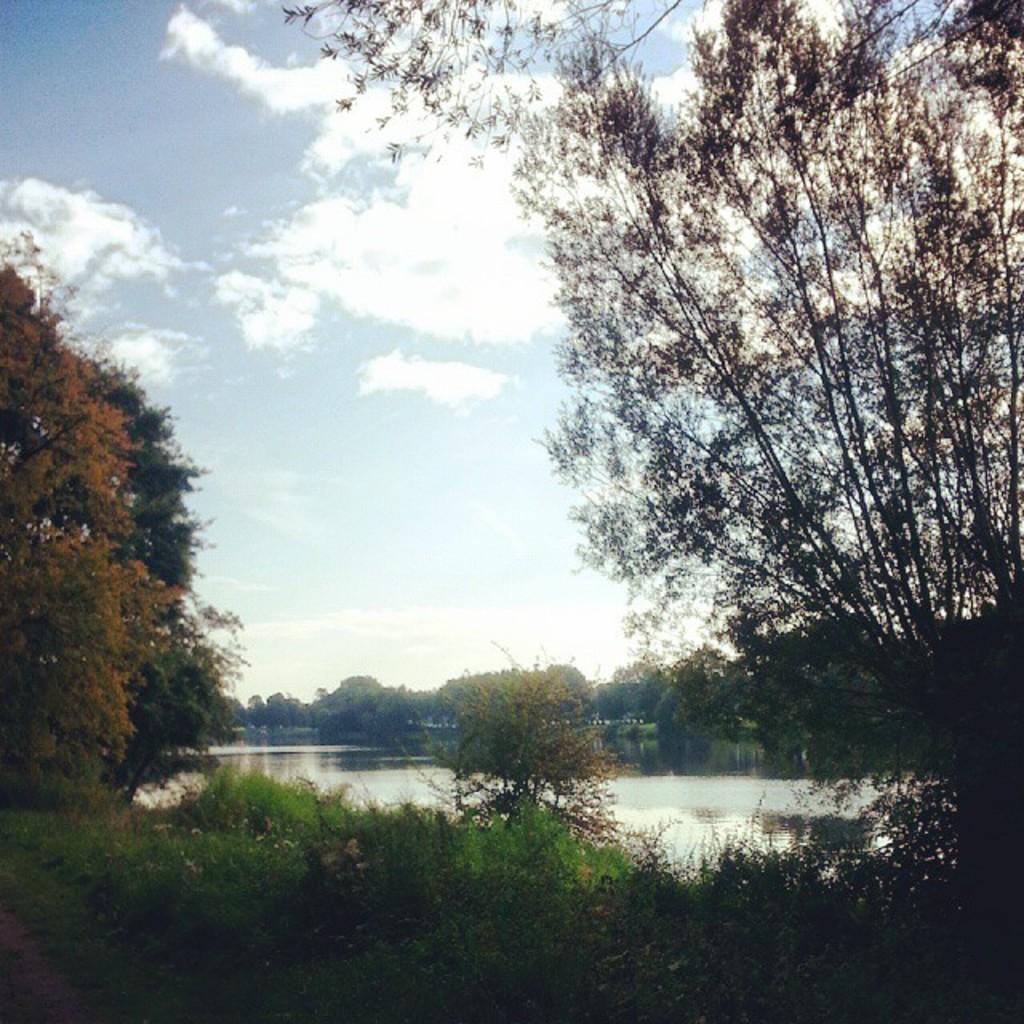In one or two sentences, can you explain what this image depicts? In this image I can see few trees in green color. In the background I can see the water and the sky is in blue and white color. 